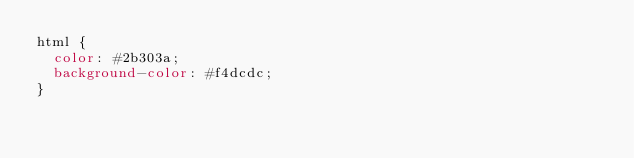<code> <loc_0><loc_0><loc_500><loc_500><_CSS_>html {
  color: #2b303a;
  background-color: #f4dcdc;
}
</code> 